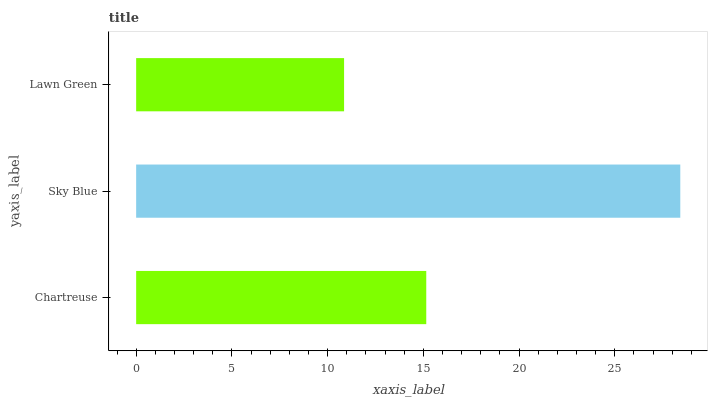Is Lawn Green the minimum?
Answer yes or no. Yes. Is Sky Blue the maximum?
Answer yes or no. Yes. Is Sky Blue the minimum?
Answer yes or no. No. Is Lawn Green the maximum?
Answer yes or no. No. Is Sky Blue greater than Lawn Green?
Answer yes or no. Yes. Is Lawn Green less than Sky Blue?
Answer yes or no. Yes. Is Lawn Green greater than Sky Blue?
Answer yes or no. No. Is Sky Blue less than Lawn Green?
Answer yes or no. No. Is Chartreuse the high median?
Answer yes or no. Yes. Is Chartreuse the low median?
Answer yes or no. Yes. Is Lawn Green the high median?
Answer yes or no. No. Is Lawn Green the low median?
Answer yes or no. No. 